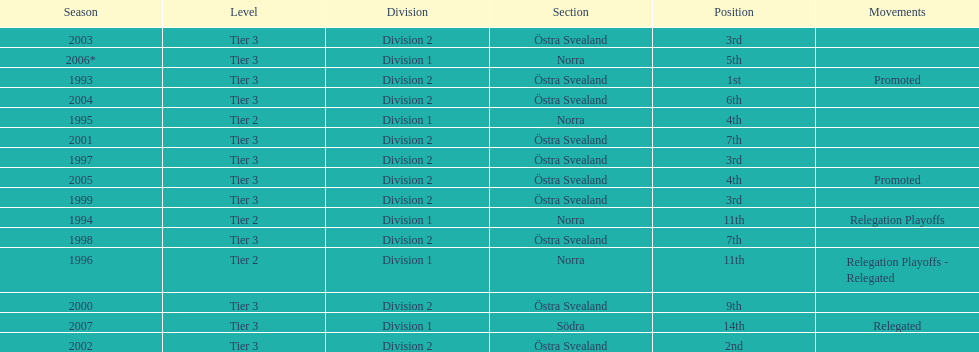What is listed under the movements column of the last season? Relegated. 